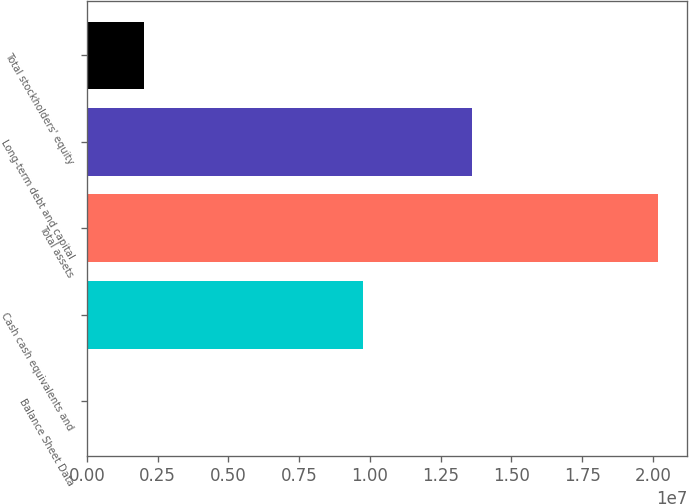Convert chart to OTSL. <chart><loc_0><loc_0><loc_500><loc_500><bar_chart><fcel>Balance Sheet Data<fcel>Cash cash equivalents and<fcel>Total assets<fcel>Long-term debt and capital<fcel>Total stockholders' equity<nl><fcel>2013<fcel>9.7394e+06<fcel>2.01921e+07<fcel>1.35972e+07<fcel>2.02102e+06<nl></chart> 